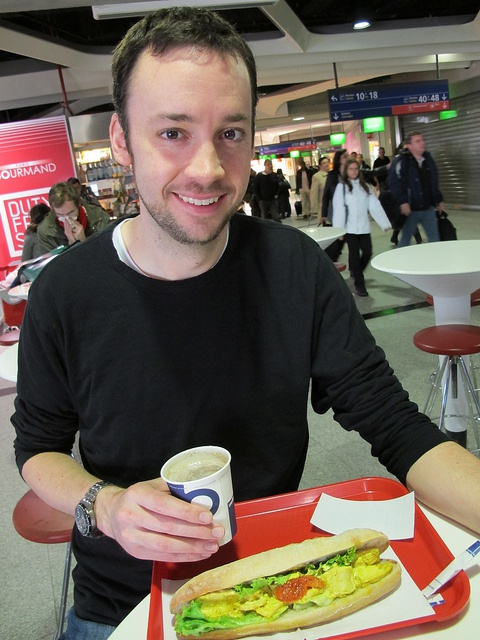Describe the objects in this image and their specific colors. I can see people in gray, black, tan, and darkgray tones, sandwich in gray, khaki, olive, and tan tones, dining table in gray, darkgray, and beige tones, dining table in gray, beige, brown, and tan tones, and cup in gray, beige, lightgray, darkgray, and blue tones in this image. 